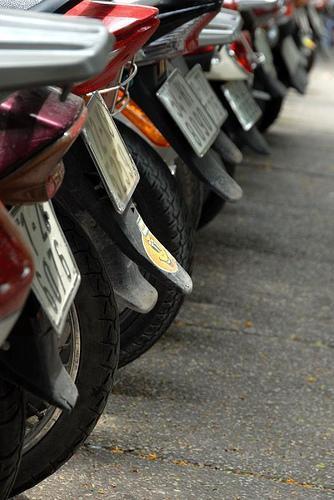How many motorcycles are there?
Give a very brief answer. 9. 